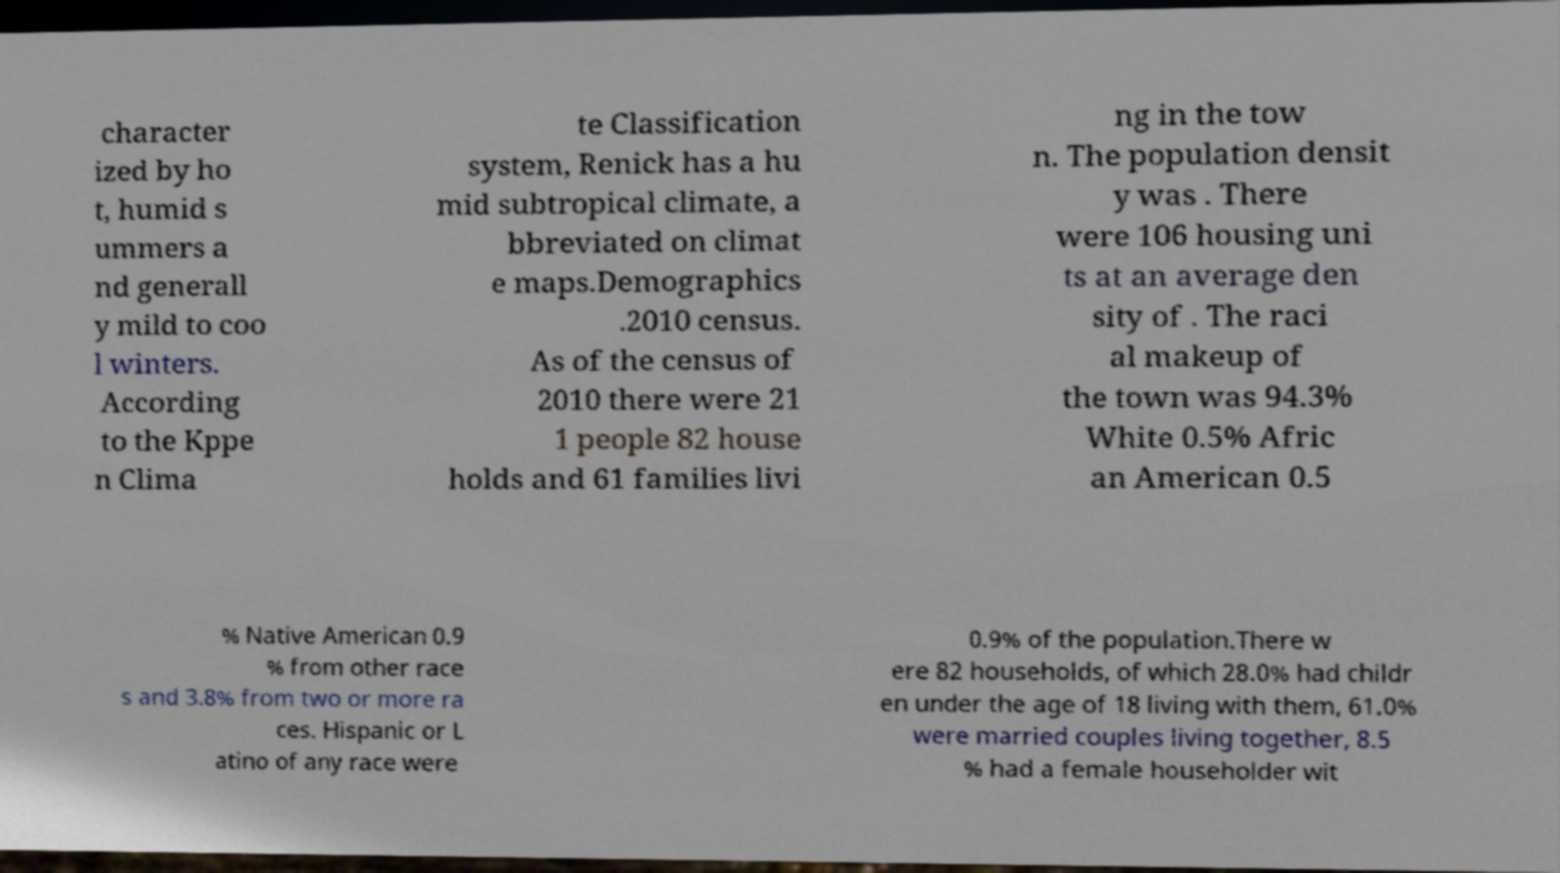Could you extract and type out the text from this image? character ized by ho t, humid s ummers a nd generall y mild to coo l winters. According to the Kppe n Clima te Classification system, Renick has a hu mid subtropical climate, a bbreviated on climat e maps.Demographics .2010 census. As of the census of 2010 there were 21 1 people 82 house holds and 61 families livi ng in the tow n. The population densit y was . There were 106 housing uni ts at an average den sity of . The raci al makeup of the town was 94.3% White 0.5% Afric an American 0.5 % Native American 0.9 % from other race s and 3.8% from two or more ra ces. Hispanic or L atino of any race were 0.9% of the population.There w ere 82 households, of which 28.0% had childr en under the age of 18 living with them, 61.0% were married couples living together, 8.5 % had a female householder wit 